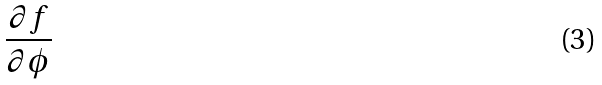<formula> <loc_0><loc_0><loc_500><loc_500>\frac { \partial f } { \partial \phi }</formula> 